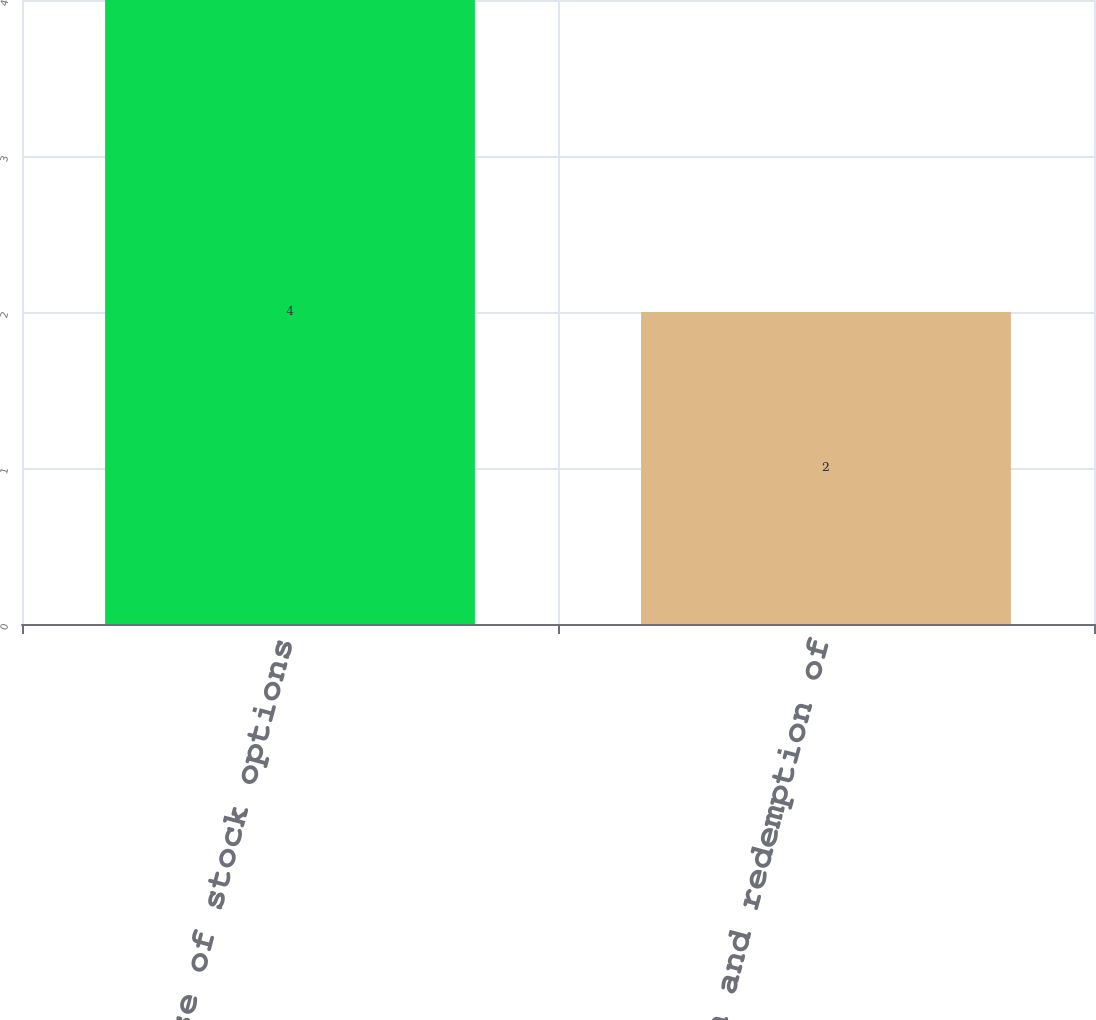<chart> <loc_0><loc_0><loc_500><loc_500><bar_chart><fcel>Exercise of stock options<fcel>Conversion and redemption of<nl><fcel>4<fcel>2<nl></chart> 